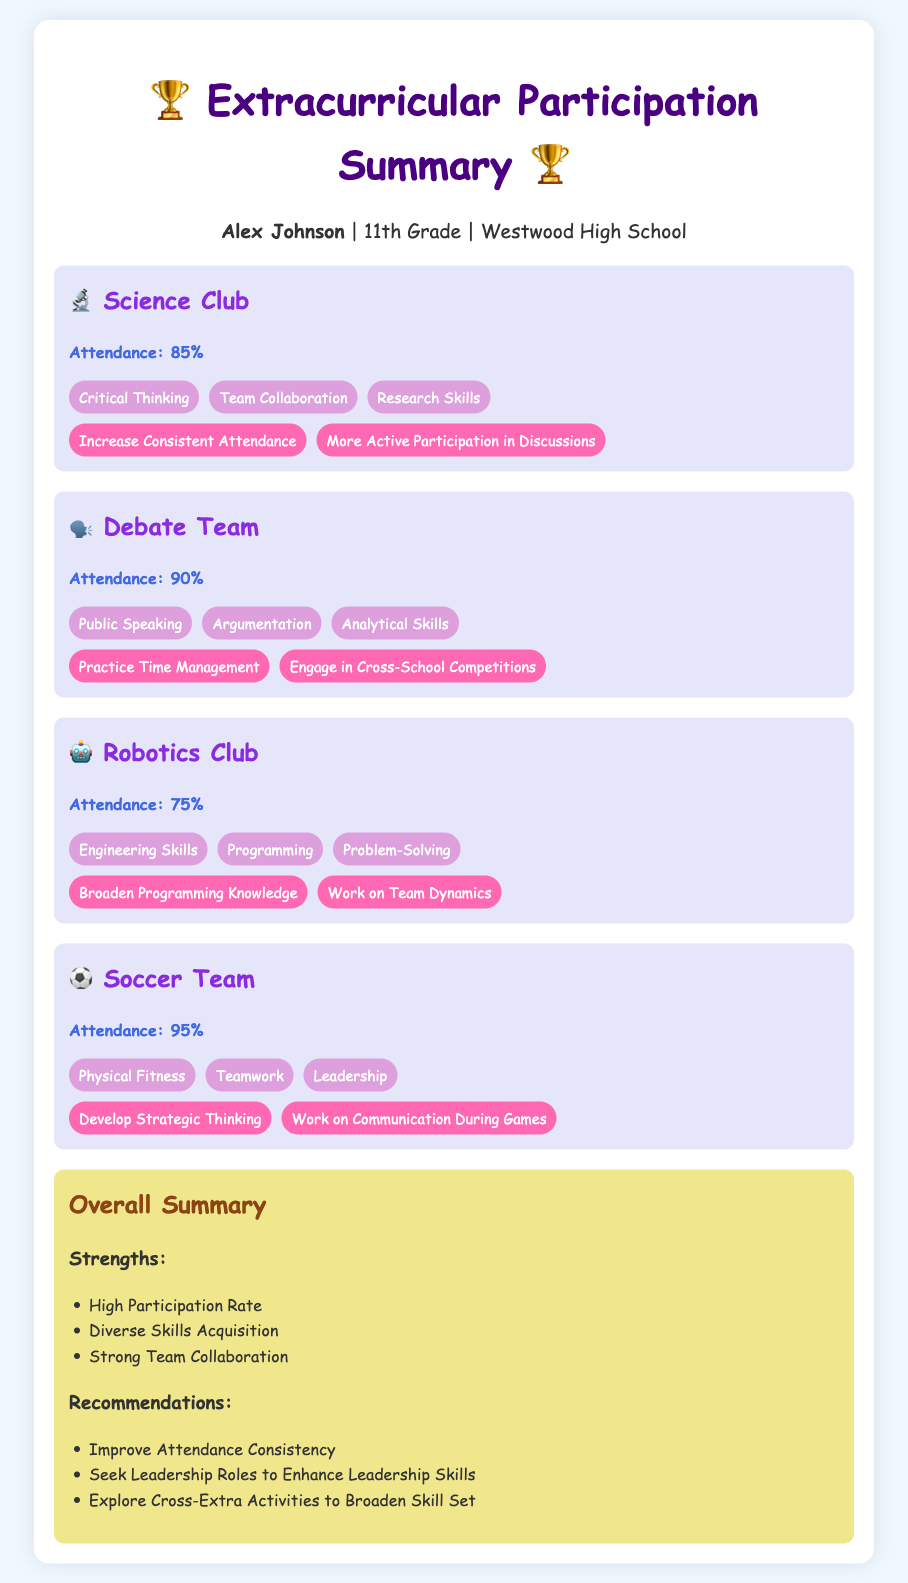What is Alex's grade? The document states that Alex is in 11th Grade.
Answer: 11th Grade What is the attendance percentage for the Soccer Team? The attendance for the Soccer Team is listed as 95%.
Answer: 95% Which skill is associated with the Science Club? The skills developed in the Science Club include Critical Thinking, Team Collaboration, and Research Skills.
Answer: Critical Thinking What are the areas of improvement for the Robotics Club? The areas of improvement for the Robotics Club include Broaden Programming Knowledge and Work on Team Dynamics.
Answer: Broaden Programming Knowledge Which extracurricular activity has the highest attendance? The attendance percentages are compared, and Soccer Team has the highest attendance.
Answer: Soccer Team How many skills are listed for the Debate Team? The skills listed for the Debate Team include Public Speaking, Argumentation, and Analytical Skills, totaling three skills.
Answer: Three What recommendation is made regarding attendance? The summary recommends improving attendance consistency.
Answer: Improve Attendance Consistency What is a strength mentioned in the overall summary? The summary mentions High Participation Rate as one of the strengths.
Answer: High Participation Rate 